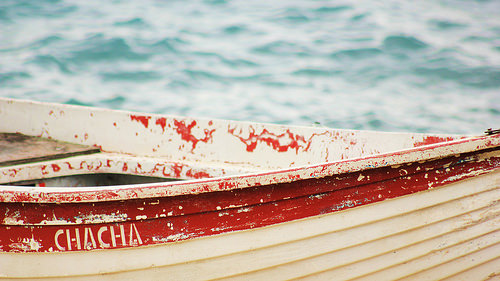<image>
Is the blood under the boat? No. The blood is not positioned under the boat. The vertical relationship between these objects is different. 